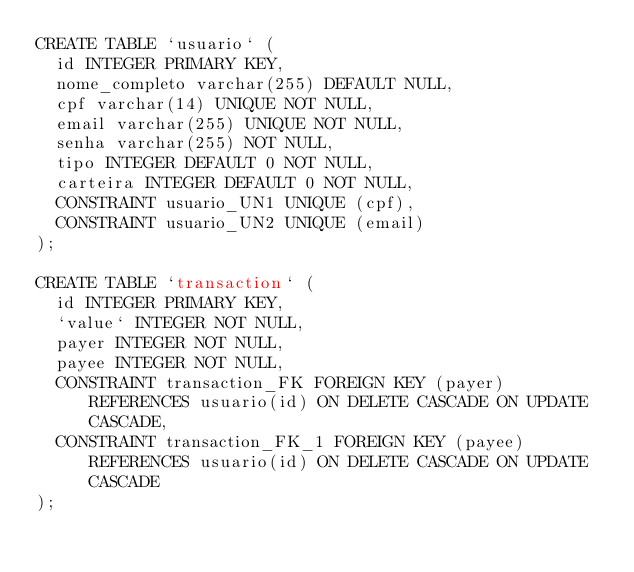<code> <loc_0><loc_0><loc_500><loc_500><_SQL_>CREATE TABLE `usuario` (
  id INTEGER PRIMARY KEY,
  nome_completo varchar(255) DEFAULT NULL,
  cpf varchar(14) UNIQUE NOT NULL,
  email varchar(255) UNIQUE NOT NULL,
  senha varchar(255) NOT NULL,
  tipo INTEGER DEFAULT 0 NOT NULL, 
  carteira INTEGER DEFAULT 0 NOT NULL,
  CONSTRAINT usuario_UN1 UNIQUE (cpf),
  CONSTRAINT usuario_UN2 UNIQUE (email)
);

CREATE TABLE `transaction` (
	id INTEGER PRIMARY KEY,
	`value` INTEGER NOT NULL,
	payer INTEGER NOT NULL,
	payee INTEGER NOT NULL,
	CONSTRAINT transaction_FK FOREIGN KEY (payer) REFERENCES usuario(id) ON DELETE CASCADE ON UPDATE CASCADE,
	CONSTRAINT transaction_FK_1 FOREIGN KEY (payee) REFERENCES usuario(id) ON DELETE CASCADE ON UPDATE CASCADE
);</code> 